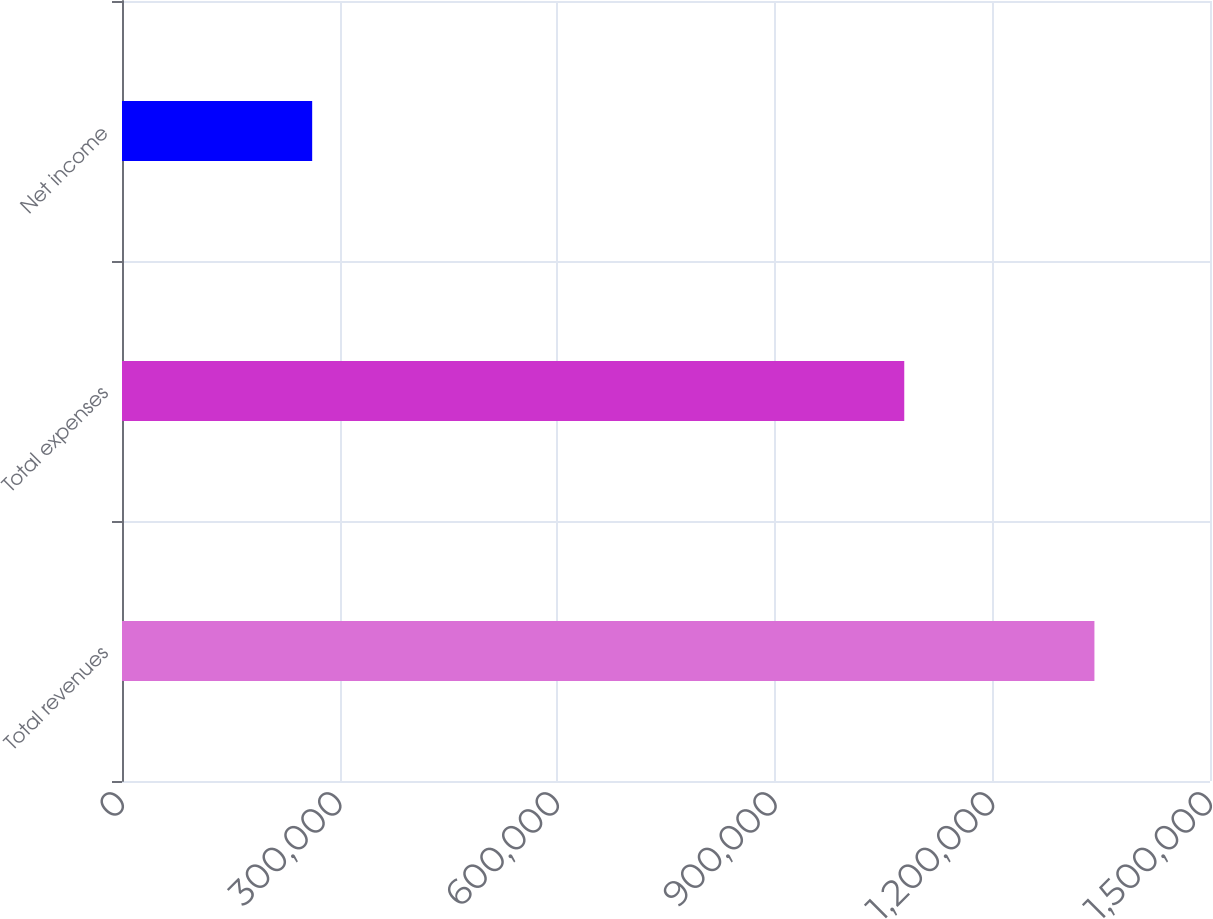Convert chart. <chart><loc_0><loc_0><loc_500><loc_500><bar_chart><fcel>Total revenues<fcel>Total expenses<fcel>Net income<nl><fcel>1.34066e+06<fcel>1.07847e+06<fcel>262192<nl></chart> 